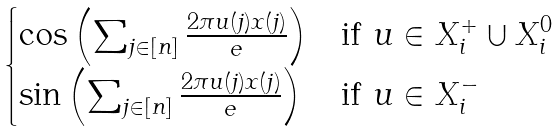Convert formula to latex. <formula><loc_0><loc_0><loc_500><loc_500>\begin{cases} \cos \left ( \sum _ { j \in [ n ] } \frac { 2 \pi u ( j ) x ( j ) } e \right ) & \text {if } u \in X _ { i } ^ { + } \cup X _ { i } ^ { 0 } \\ \sin \left ( \sum _ { j \in [ n ] } \frac { 2 \pi u ( j ) x ( j ) } e \right ) & \text {if } u \in X _ { i } ^ { - } \end{cases}</formula> 